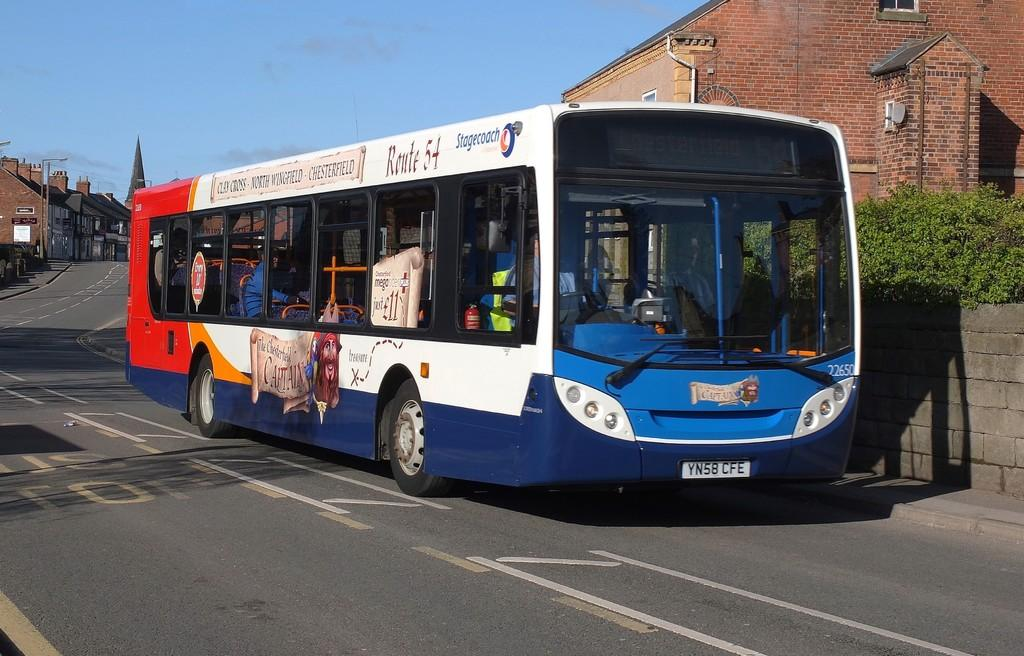Provide a one-sentence caption for the provided image. A bus on Route 54 waiting at the curb. 